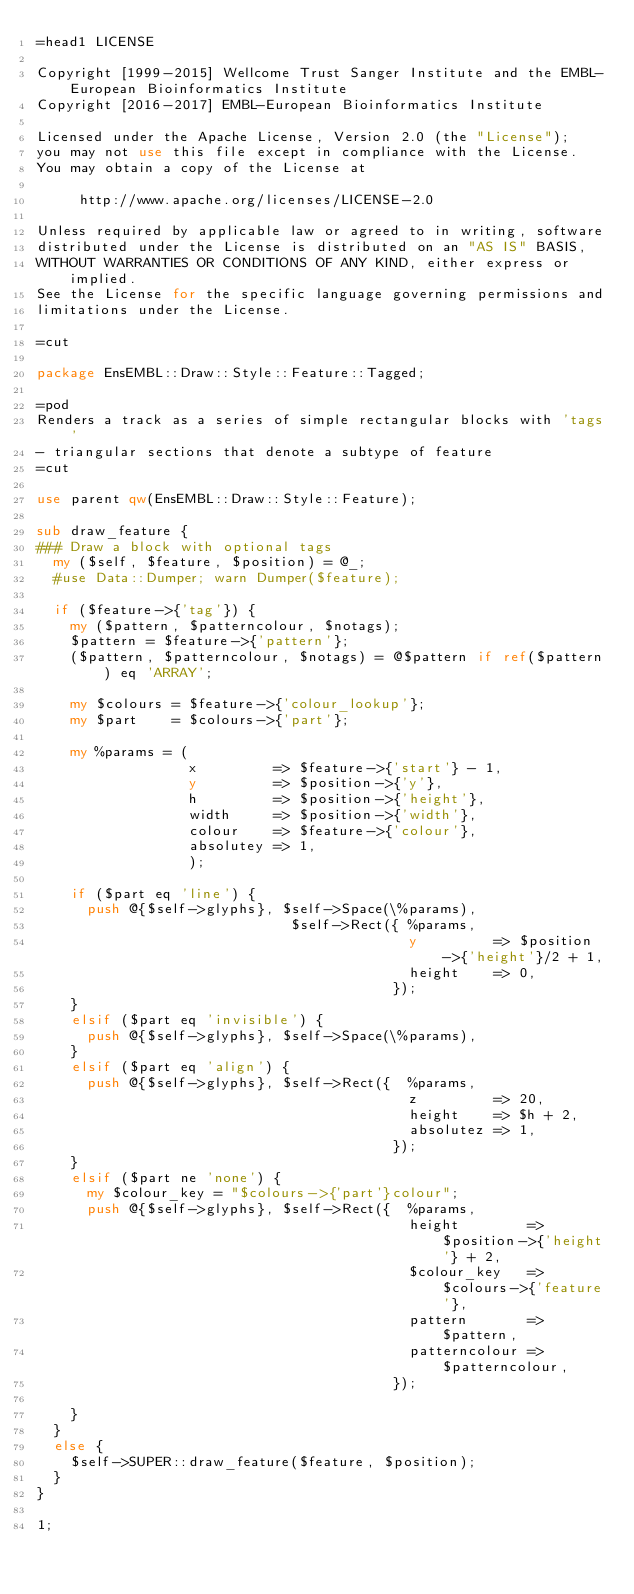<code> <loc_0><loc_0><loc_500><loc_500><_Perl_>=head1 LICENSE

Copyright [1999-2015] Wellcome Trust Sanger Institute and the EMBL-European Bioinformatics Institute
Copyright [2016-2017] EMBL-European Bioinformatics Institute

Licensed under the Apache License, Version 2.0 (the "License");
you may not use this file except in compliance with the License.
You may obtain a copy of the License at

     http://www.apache.org/licenses/LICENSE-2.0

Unless required by applicable law or agreed to in writing, software
distributed under the License is distributed on an "AS IS" BASIS,
WITHOUT WARRANTIES OR CONDITIONS OF ANY KIND, either express or implied.
See the License for the specific language governing permissions and
limitations under the License.

=cut

package EnsEMBL::Draw::Style::Feature::Tagged;

=pod
Renders a track as a series of simple rectangular blocks with 'tags' 
- triangular sections that denote a subtype of feature
=cut

use parent qw(EnsEMBL::Draw::Style::Feature);

sub draw_feature {
### Draw a block with optional tags
  my ($self, $feature, $position) = @_;
  #use Data::Dumper; warn Dumper($feature);

  if ($feature->{'tag'}) {
    my ($pattern, $patterncolour, $notags);
    $pattern = $feature->{'pattern'};
    ($pattern, $patterncolour, $notags) = @$pattern if ref($pattern) eq 'ARRAY';

    my $colours = $feature->{'colour_lookup'};
    my $part    = $colours->{'part'};

    my %params = (
                  x         => $feature->{'start'} - 1,
                  y         => $position->{'y'},
                  h         => $position->{'height'},
                  width     => $position->{'width'},
                  colour    => $feature->{'colour'},
                  absolutey => 1,
                  );

    if ($part eq 'line') {
      push @{$self->glyphs}, $self->Space(\%params),
                              $self->Rect({ %params,
                                            y         => $position->{'height'}/2 + 1,
                                            height    => 0,
                                          });
    }
    elsif ($part eq 'invisible') { 
      push @{$self->glyphs}, $self->Space(\%params),
    } 
    elsif ($part eq 'align') {
      push @{$self->glyphs}, $self->Rect({  %params,
                                            z         => 20,
                                            height    => $h + 2,
                                            absolutez => 1,
                                          });
    }
    elsif ($part ne 'none') {
      my $colour_key = "$colours->{'part'}colour";
      push @{$self->glyphs}, $self->Rect({  %params,
                                            height        => $position->{'height'} + 2,
                                            $colour_key   => $colours->{'feature'},
                                            pattern       => $pattern,
                                            patterncolour => $patterncolour,
                                          });

    }
  }
  else {
    $self->SUPER::draw_feature($feature, $position);
  }
}

1;
</code> 